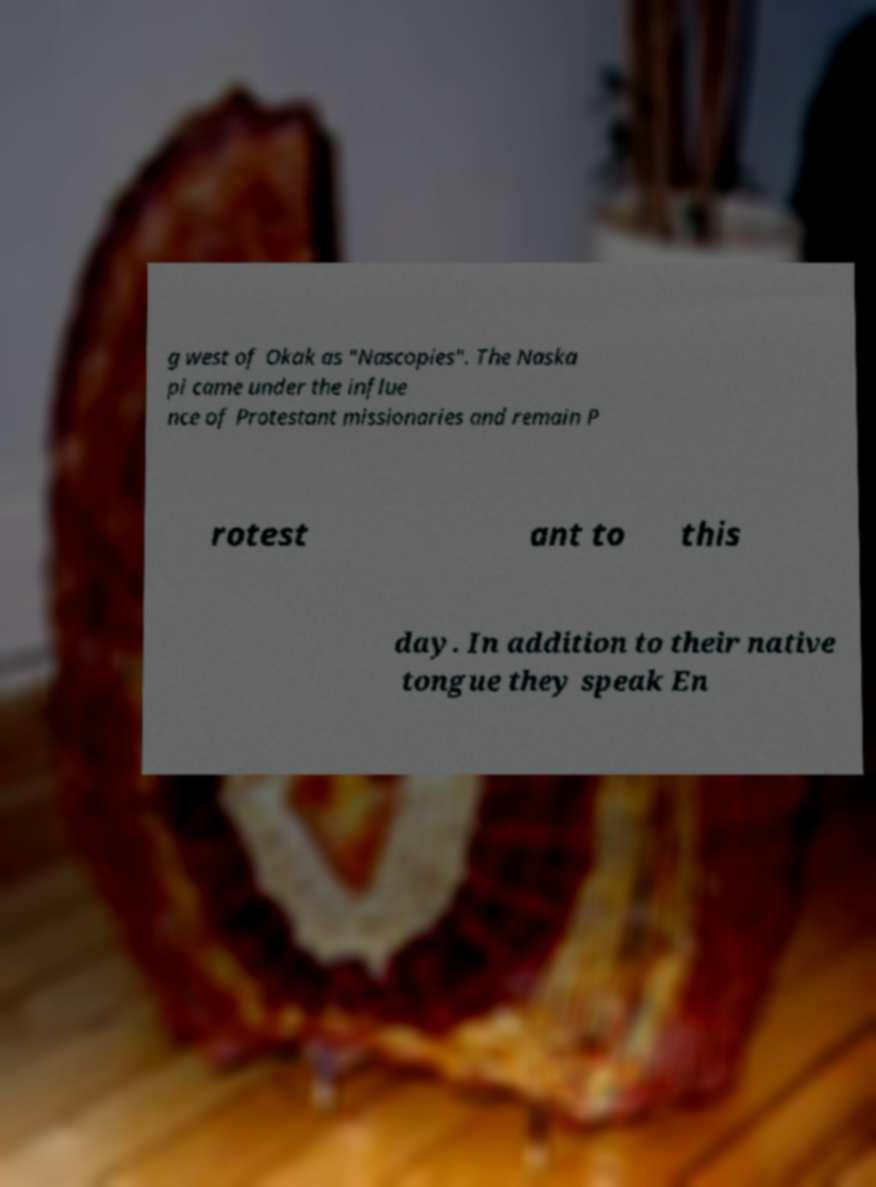Please identify and transcribe the text found in this image. g west of Okak as "Nascopies". The Naska pi came under the influe nce of Protestant missionaries and remain P rotest ant to this day. In addition to their native tongue they speak En 